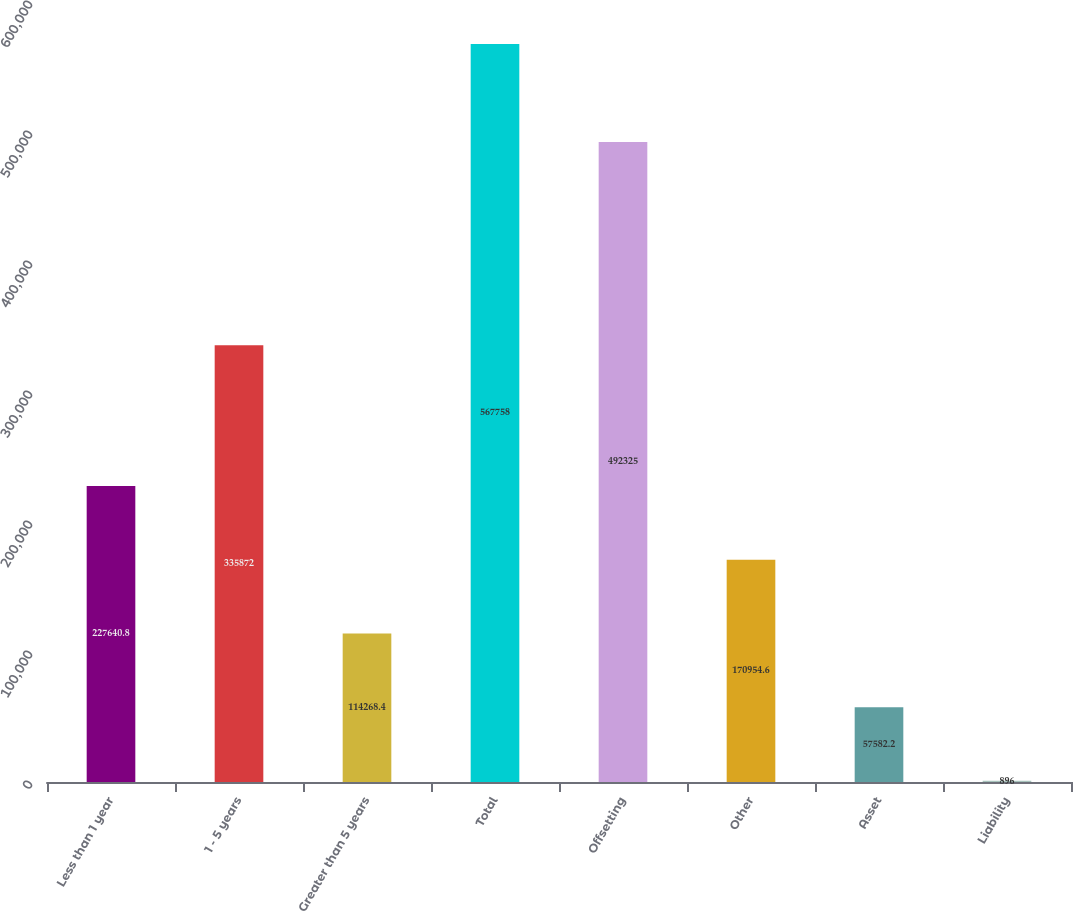<chart> <loc_0><loc_0><loc_500><loc_500><bar_chart><fcel>Less than 1 year<fcel>1 - 5 years<fcel>Greater than 5 years<fcel>Total<fcel>Offsetting<fcel>Other<fcel>Asset<fcel>Liability<nl><fcel>227641<fcel>335872<fcel>114268<fcel>567758<fcel>492325<fcel>170955<fcel>57582.2<fcel>896<nl></chart> 